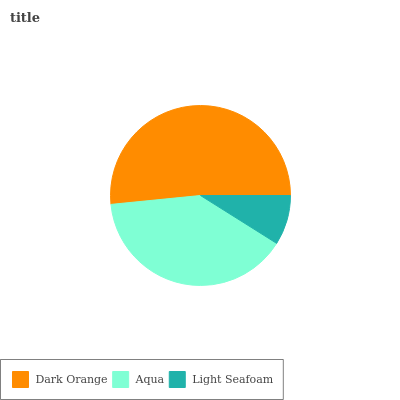Is Light Seafoam the minimum?
Answer yes or no. Yes. Is Dark Orange the maximum?
Answer yes or no. Yes. Is Aqua the minimum?
Answer yes or no. No. Is Aqua the maximum?
Answer yes or no. No. Is Dark Orange greater than Aqua?
Answer yes or no. Yes. Is Aqua less than Dark Orange?
Answer yes or no. Yes. Is Aqua greater than Dark Orange?
Answer yes or no. No. Is Dark Orange less than Aqua?
Answer yes or no. No. Is Aqua the high median?
Answer yes or no. Yes. Is Aqua the low median?
Answer yes or no. Yes. Is Dark Orange the high median?
Answer yes or no. No. Is Light Seafoam the low median?
Answer yes or no. No. 